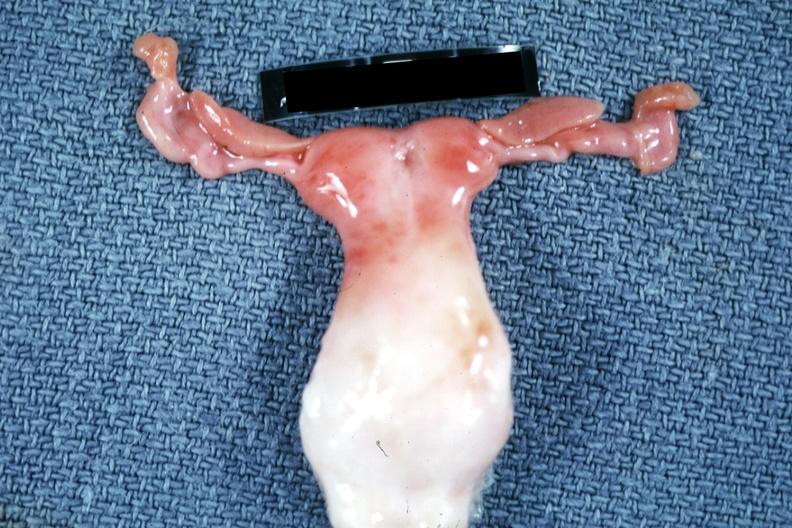what is present?
Answer the question using a single word or phrase. Female reproductive 